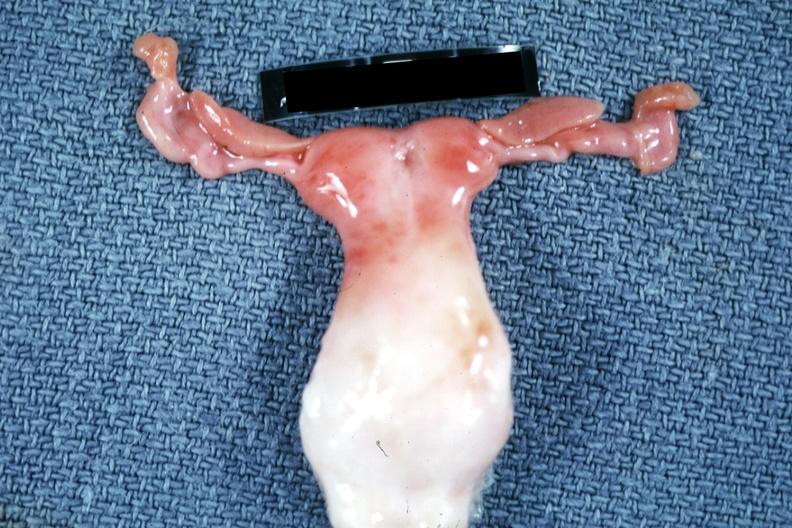what is present?
Answer the question using a single word or phrase. Female reproductive 